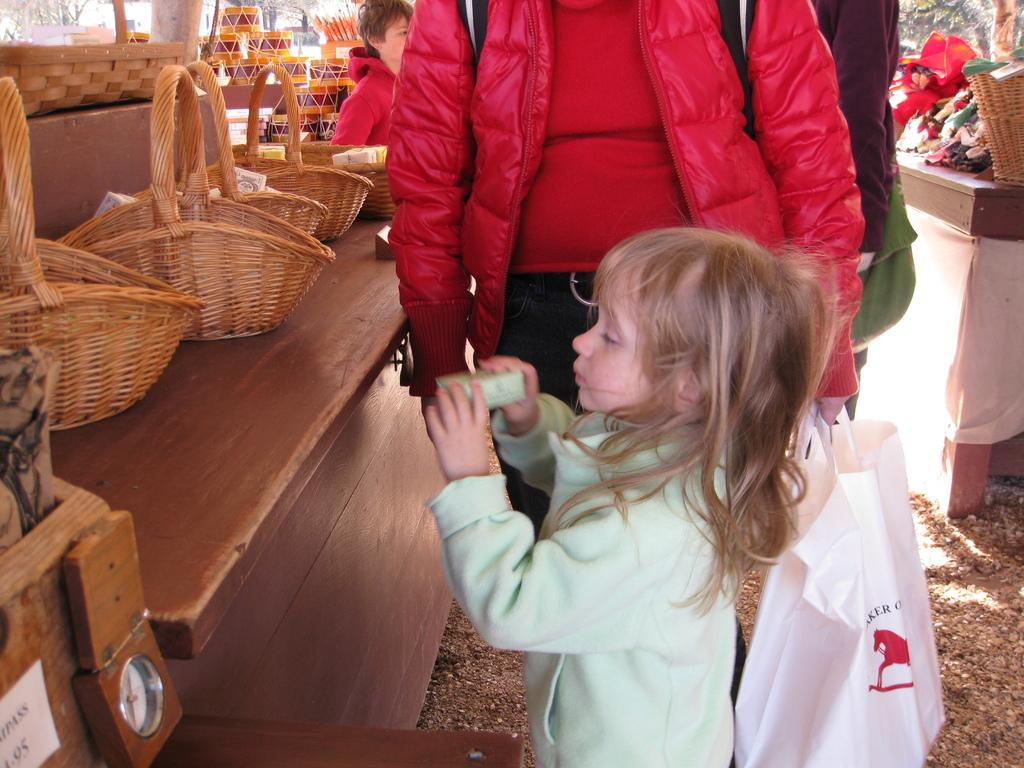What are the people in the image doing? The people in the image are standing on the floor. Can you describe the person holding the white plastic cover? The person holding the cover is wearing a red jacket. What is on the table in the image? There are baskets on the table in the image. Which direction is the goose facing in the image? There is no goose present in the image. How many fingers does the person holding the cover have? The number of fingers the person holding the cover has cannot be determined from the image. 